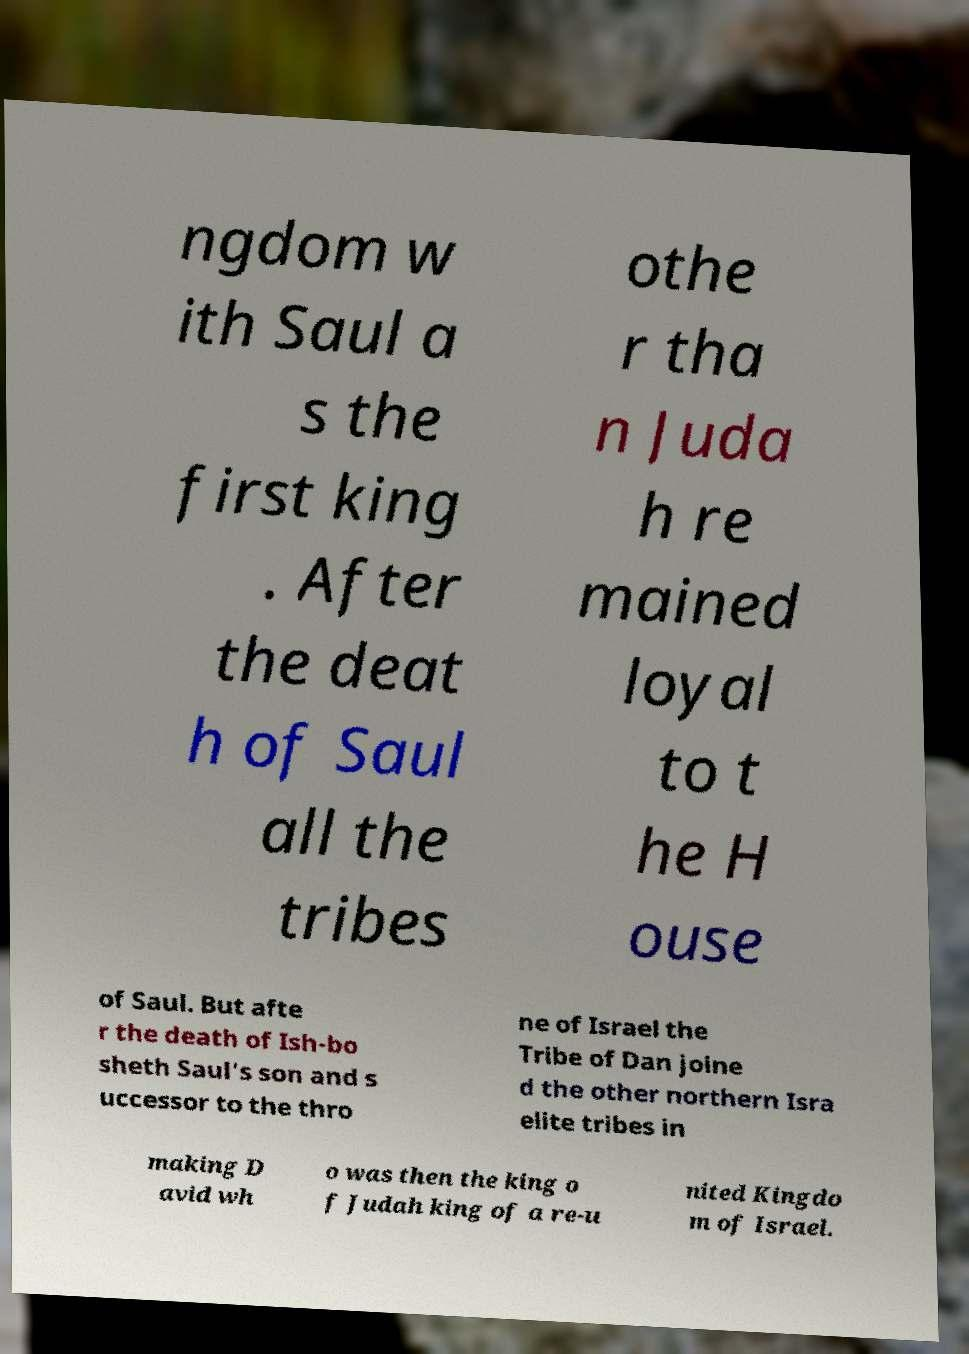I need the written content from this picture converted into text. Can you do that? ngdom w ith Saul a s the first king . After the deat h of Saul all the tribes othe r tha n Juda h re mained loyal to t he H ouse of Saul. But afte r the death of Ish-bo sheth Saul's son and s uccessor to the thro ne of Israel the Tribe of Dan joine d the other northern Isra elite tribes in making D avid wh o was then the king o f Judah king of a re-u nited Kingdo m of Israel. 